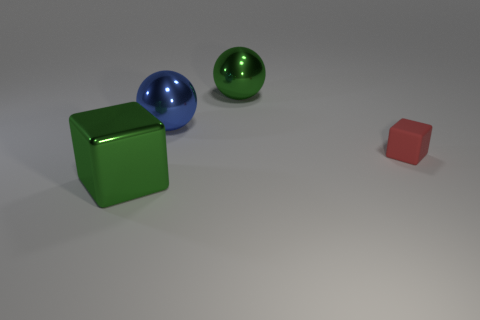Add 2 large purple metal things. How many objects exist? 6 Subtract all tiny red matte objects. Subtract all metal objects. How many objects are left? 0 Add 4 big blue shiny things. How many big blue shiny things are left? 5 Add 4 big green objects. How many big green objects exist? 6 Subtract 0 purple cylinders. How many objects are left? 4 